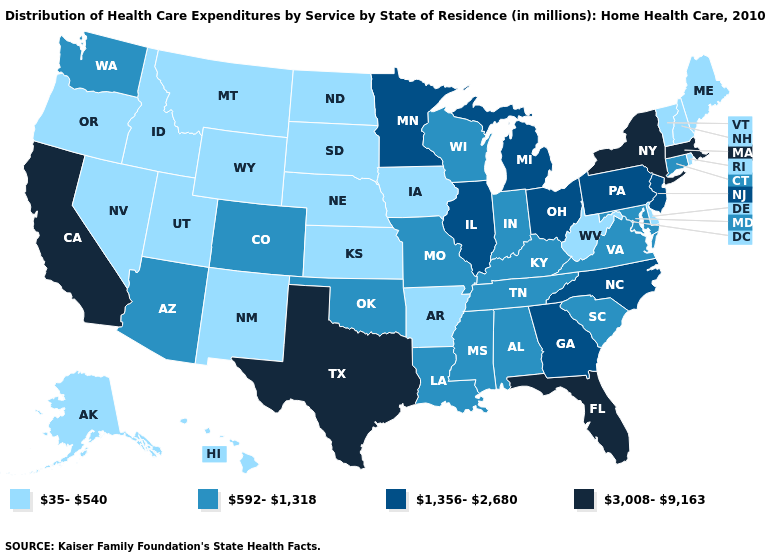What is the lowest value in the West?
Be succinct. 35-540. What is the highest value in the South ?
Concise answer only. 3,008-9,163. Does the first symbol in the legend represent the smallest category?
Write a very short answer. Yes. What is the highest value in states that border Washington?
Quick response, please. 35-540. What is the value of North Carolina?
Concise answer only. 1,356-2,680. Which states have the highest value in the USA?
Answer briefly. California, Florida, Massachusetts, New York, Texas. Name the states that have a value in the range 1,356-2,680?
Write a very short answer. Georgia, Illinois, Michigan, Minnesota, New Jersey, North Carolina, Ohio, Pennsylvania. Is the legend a continuous bar?
Short answer required. No. Name the states that have a value in the range 3,008-9,163?
Short answer required. California, Florida, Massachusetts, New York, Texas. Which states have the highest value in the USA?
Short answer required. California, Florida, Massachusetts, New York, Texas. What is the highest value in states that border South Carolina?
Quick response, please. 1,356-2,680. Which states have the lowest value in the MidWest?
Give a very brief answer. Iowa, Kansas, Nebraska, North Dakota, South Dakota. Name the states that have a value in the range 1,356-2,680?
Answer briefly. Georgia, Illinois, Michigan, Minnesota, New Jersey, North Carolina, Ohio, Pennsylvania. Name the states that have a value in the range 3,008-9,163?
Short answer required. California, Florida, Massachusetts, New York, Texas. What is the lowest value in states that border New Hampshire?
Give a very brief answer. 35-540. 